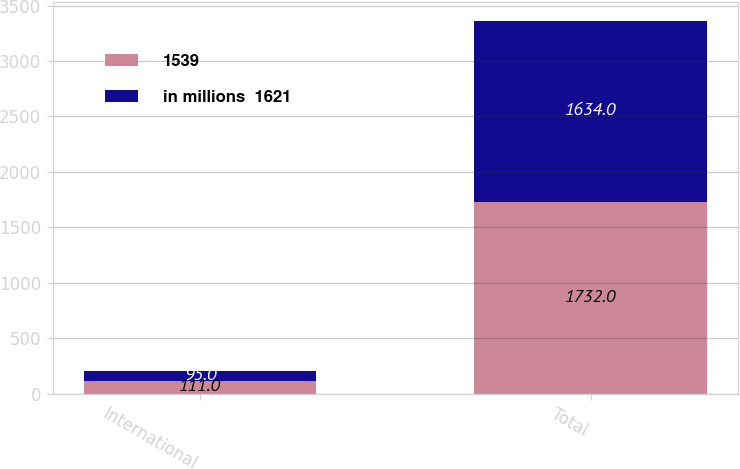<chart> <loc_0><loc_0><loc_500><loc_500><stacked_bar_chart><ecel><fcel>International<fcel>Total<nl><fcel>1539<fcel>111<fcel>1732<nl><fcel>in millions  1621<fcel>95<fcel>1634<nl></chart> 